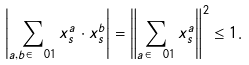Convert formula to latex. <formula><loc_0><loc_0><loc_500><loc_500>\left | \sum _ { a , b \in \ 0 1 } x _ { s } ^ { a } \cdot x _ { s } ^ { b } \right | = \left \| \sum _ { a \in \ 0 1 } x _ { s } ^ { a } \right \| ^ { 2 } \leq 1 .</formula> 